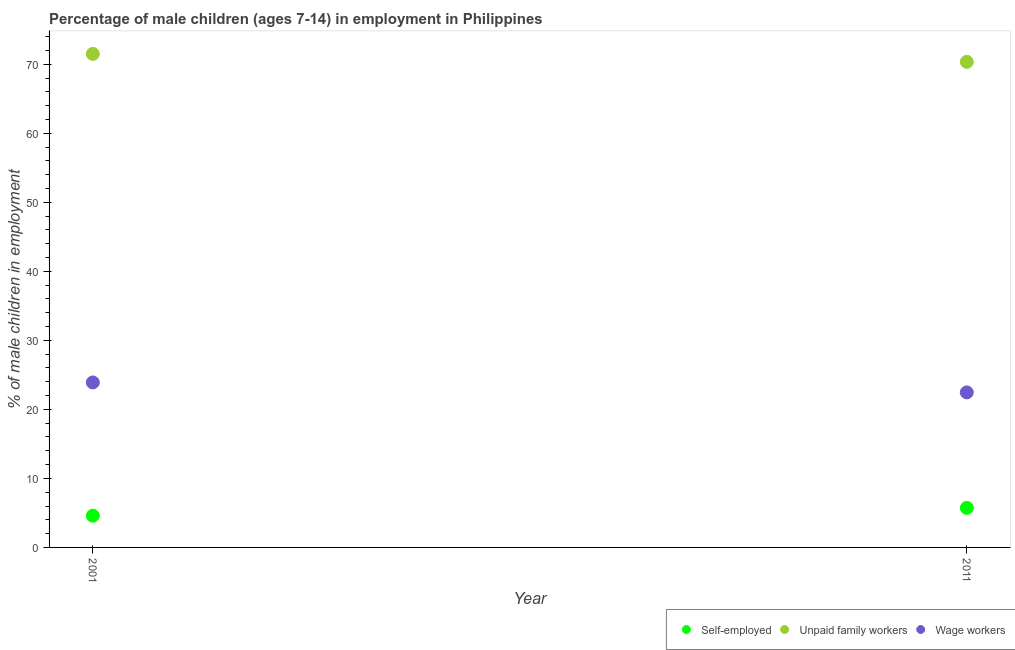How many different coloured dotlines are there?
Provide a short and direct response. 3. What is the percentage of children employed as wage workers in 2011?
Ensure brevity in your answer.  22.46. Across all years, what is the maximum percentage of children employed as unpaid family workers?
Offer a terse response. 71.5. Across all years, what is the minimum percentage of children employed as wage workers?
Keep it short and to the point. 22.46. In which year was the percentage of children employed as unpaid family workers maximum?
Your response must be concise. 2001. What is the total percentage of children employed as unpaid family workers in the graph?
Provide a succinct answer. 141.85. What is the difference between the percentage of children employed as wage workers in 2001 and that in 2011?
Your answer should be compact. 1.44. What is the difference between the percentage of children employed as wage workers in 2011 and the percentage of children employed as unpaid family workers in 2001?
Keep it short and to the point. -49.04. What is the average percentage of self employed children per year?
Give a very brief answer. 5.17. In the year 2011, what is the difference between the percentage of self employed children and percentage of children employed as unpaid family workers?
Provide a short and direct response. -64.62. In how many years, is the percentage of children employed as unpaid family workers greater than 72 %?
Ensure brevity in your answer.  0. What is the ratio of the percentage of self employed children in 2001 to that in 2011?
Offer a terse response. 0.8. Is the percentage of self employed children in 2001 less than that in 2011?
Offer a very short reply. Yes. Does the percentage of children employed as wage workers monotonically increase over the years?
Provide a succinct answer. No. Is the percentage of children employed as wage workers strictly greater than the percentage of self employed children over the years?
Offer a very short reply. Yes. Is the percentage of self employed children strictly less than the percentage of children employed as unpaid family workers over the years?
Provide a short and direct response. Yes. Are the values on the major ticks of Y-axis written in scientific E-notation?
Keep it short and to the point. No. Does the graph contain any zero values?
Provide a short and direct response. No. How are the legend labels stacked?
Give a very brief answer. Horizontal. What is the title of the graph?
Give a very brief answer. Percentage of male children (ages 7-14) in employment in Philippines. What is the label or title of the X-axis?
Ensure brevity in your answer.  Year. What is the label or title of the Y-axis?
Offer a very short reply. % of male children in employment. What is the % of male children in employment of Self-employed in 2001?
Give a very brief answer. 4.6. What is the % of male children in employment of Unpaid family workers in 2001?
Provide a short and direct response. 71.5. What is the % of male children in employment of Wage workers in 2001?
Offer a terse response. 23.9. What is the % of male children in employment in Self-employed in 2011?
Your answer should be very brief. 5.73. What is the % of male children in employment in Unpaid family workers in 2011?
Make the answer very short. 70.35. What is the % of male children in employment in Wage workers in 2011?
Your answer should be compact. 22.46. Across all years, what is the maximum % of male children in employment of Self-employed?
Your answer should be compact. 5.73. Across all years, what is the maximum % of male children in employment of Unpaid family workers?
Give a very brief answer. 71.5. Across all years, what is the maximum % of male children in employment in Wage workers?
Your answer should be compact. 23.9. Across all years, what is the minimum % of male children in employment of Unpaid family workers?
Ensure brevity in your answer.  70.35. Across all years, what is the minimum % of male children in employment of Wage workers?
Give a very brief answer. 22.46. What is the total % of male children in employment in Self-employed in the graph?
Your answer should be very brief. 10.33. What is the total % of male children in employment in Unpaid family workers in the graph?
Your answer should be very brief. 141.85. What is the total % of male children in employment of Wage workers in the graph?
Your answer should be compact. 46.36. What is the difference between the % of male children in employment of Self-employed in 2001 and that in 2011?
Offer a very short reply. -1.13. What is the difference between the % of male children in employment in Unpaid family workers in 2001 and that in 2011?
Your answer should be compact. 1.15. What is the difference between the % of male children in employment of Wage workers in 2001 and that in 2011?
Your answer should be compact. 1.44. What is the difference between the % of male children in employment of Self-employed in 2001 and the % of male children in employment of Unpaid family workers in 2011?
Keep it short and to the point. -65.75. What is the difference between the % of male children in employment in Self-employed in 2001 and the % of male children in employment in Wage workers in 2011?
Your answer should be very brief. -17.86. What is the difference between the % of male children in employment in Unpaid family workers in 2001 and the % of male children in employment in Wage workers in 2011?
Give a very brief answer. 49.04. What is the average % of male children in employment of Self-employed per year?
Provide a short and direct response. 5.17. What is the average % of male children in employment in Unpaid family workers per year?
Your response must be concise. 70.92. What is the average % of male children in employment in Wage workers per year?
Your answer should be very brief. 23.18. In the year 2001, what is the difference between the % of male children in employment in Self-employed and % of male children in employment in Unpaid family workers?
Ensure brevity in your answer.  -66.9. In the year 2001, what is the difference between the % of male children in employment in Self-employed and % of male children in employment in Wage workers?
Give a very brief answer. -19.3. In the year 2001, what is the difference between the % of male children in employment of Unpaid family workers and % of male children in employment of Wage workers?
Your answer should be compact. 47.6. In the year 2011, what is the difference between the % of male children in employment of Self-employed and % of male children in employment of Unpaid family workers?
Offer a terse response. -64.62. In the year 2011, what is the difference between the % of male children in employment of Self-employed and % of male children in employment of Wage workers?
Give a very brief answer. -16.73. In the year 2011, what is the difference between the % of male children in employment of Unpaid family workers and % of male children in employment of Wage workers?
Your answer should be very brief. 47.89. What is the ratio of the % of male children in employment of Self-employed in 2001 to that in 2011?
Your response must be concise. 0.8. What is the ratio of the % of male children in employment in Unpaid family workers in 2001 to that in 2011?
Give a very brief answer. 1.02. What is the ratio of the % of male children in employment of Wage workers in 2001 to that in 2011?
Provide a short and direct response. 1.06. What is the difference between the highest and the second highest % of male children in employment in Self-employed?
Your answer should be very brief. 1.13. What is the difference between the highest and the second highest % of male children in employment in Unpaid family workers?
Your answer should be very brief. 1.15. What is the difference between the highest and the second highest % of male children in employment in Wage workers?
Your answer should be very brief. 1.44. What is the difference between the highest and the lowest % of male children in employment in Self-employed?
Make the answer very short. 1.13. What is the difference between the highest and the lowest % of male children in employment of Unpaid family workers?
Keep it short and to the point. 1.15. What is the difference between the highest and the lowest % of male children in employment in Wage workers?
Offer a terse response. 1.44. 